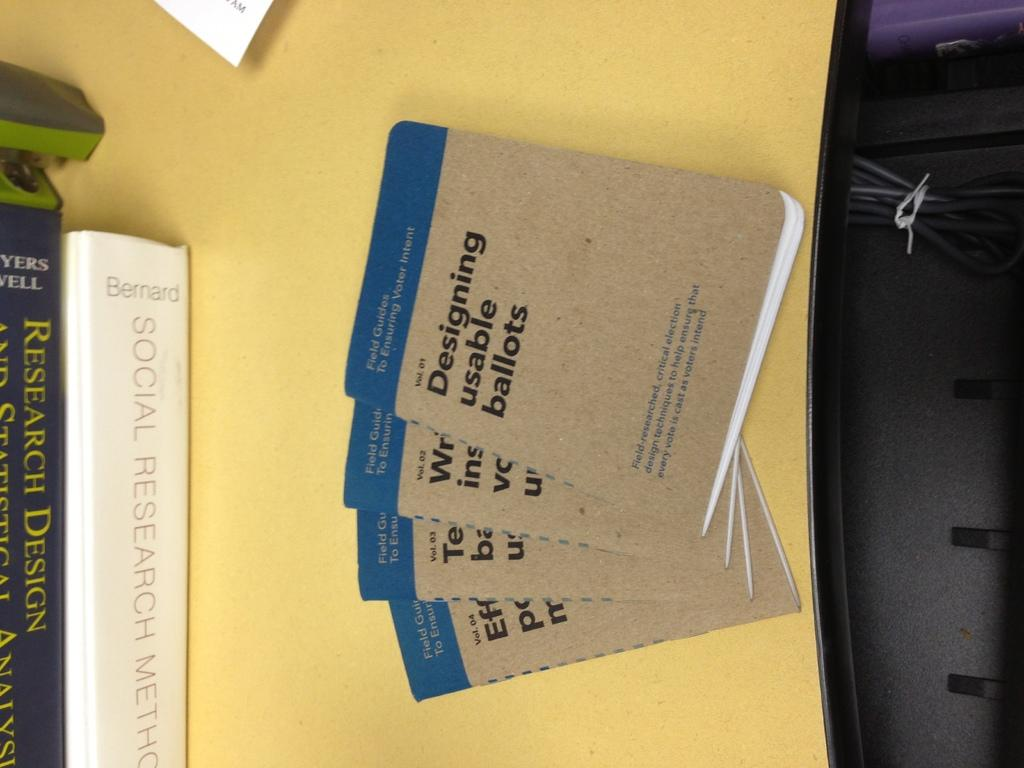<image>
Offer a succinct explanation of the picture presented. Several research books sit on a table next to a series of books entitled "Field Guides to Ensuring Voter Intent" 